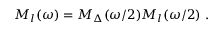<formula> <loc_0><loc_0><loc_500><loc_500>M _ { l } ( \omega ) = M _ { \Delta } ( \omega / 2 ) M _ { l } ( \omega / 2 ) \ .</formula> 